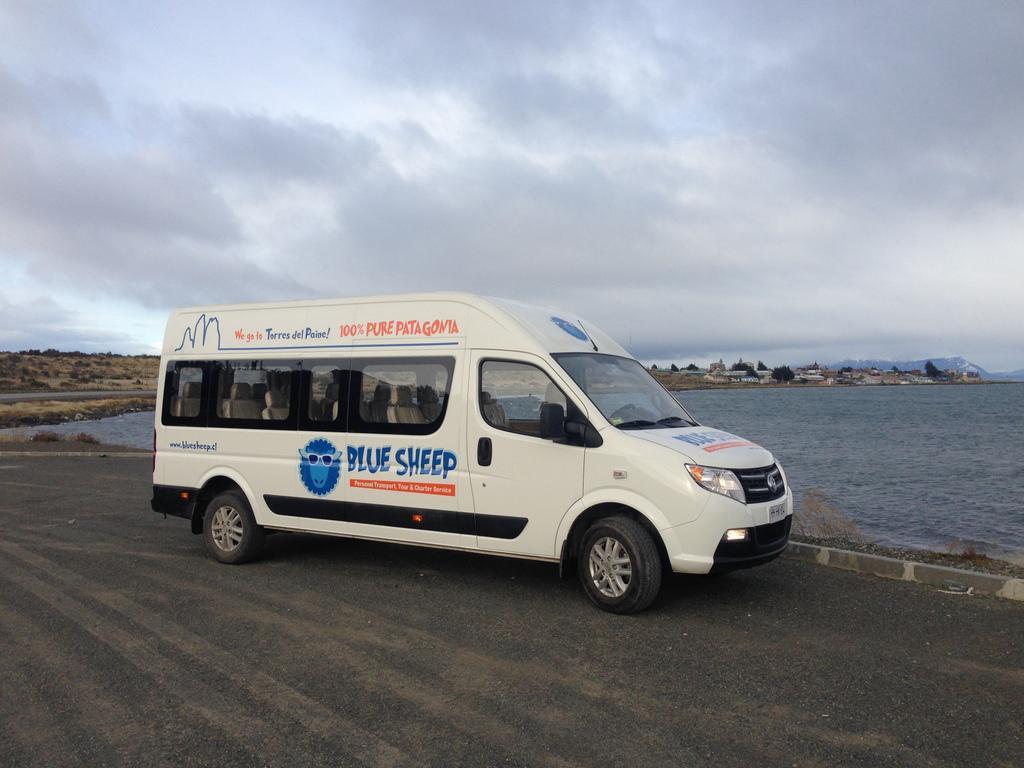What is this bus for?
Offer a terse response. Blue sheep. 